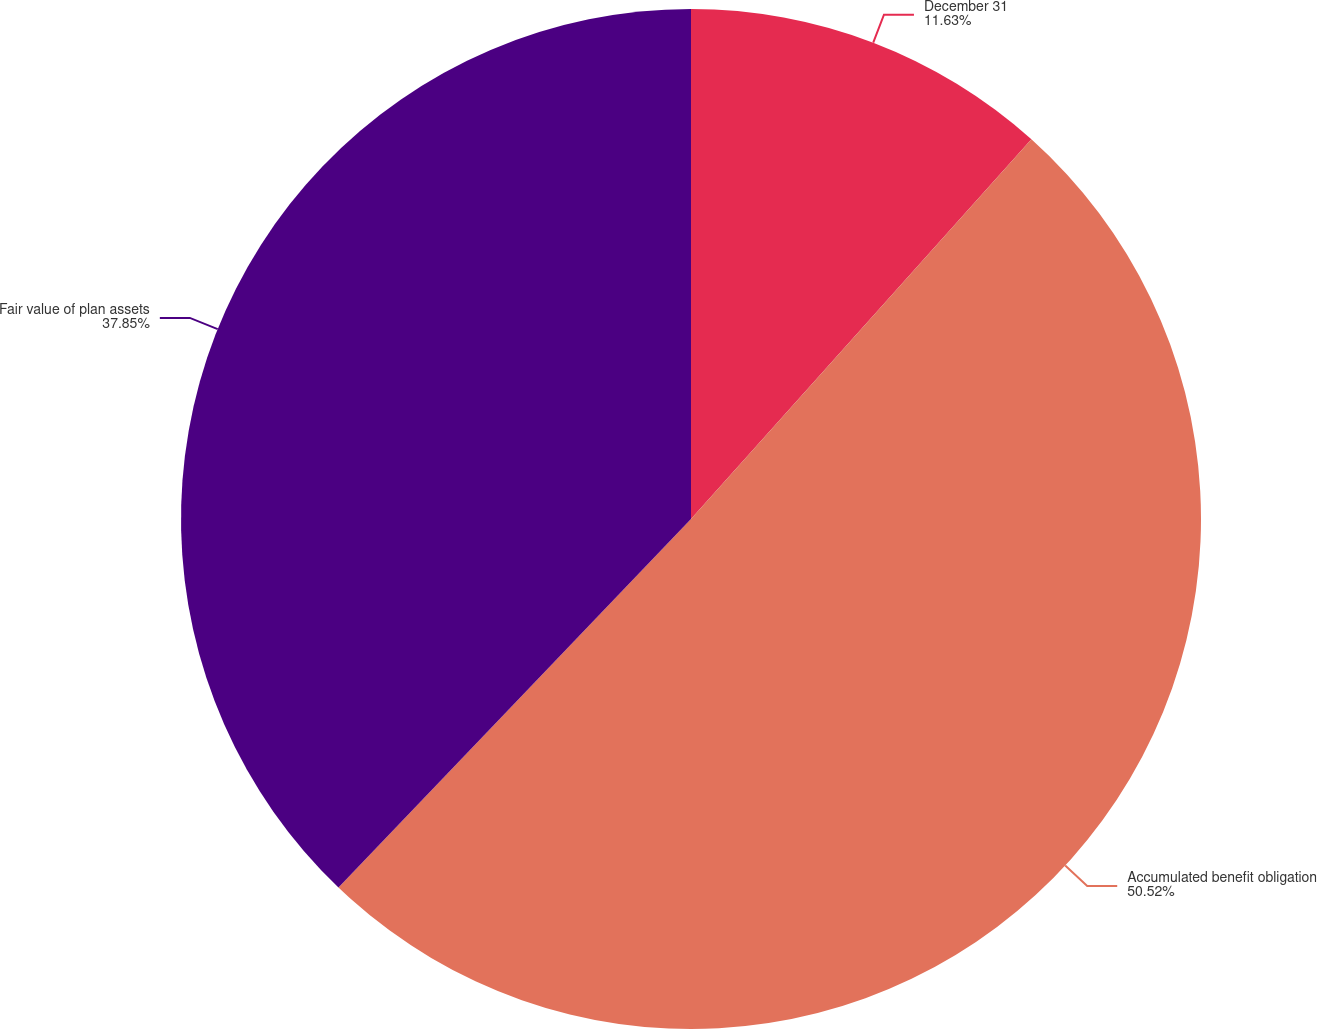Convert chart. <chart><loc_0><loc_0><loc_500><loc_500><pie_chart><fcel>December 31<fcel>Accumulated benefit obligation<fcel>Fair value of plan assets<nl><fcel>11.63%<fcel>50.51%<fcel>37.85%<nl></chart> 